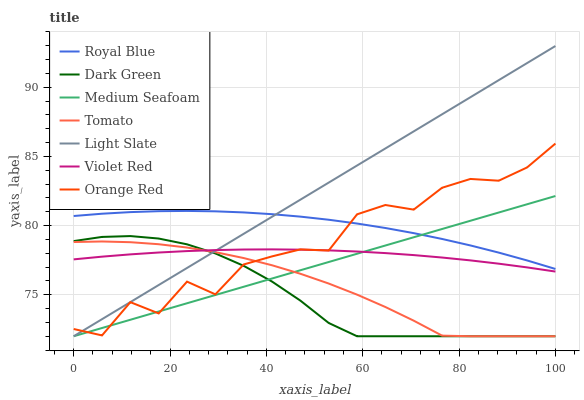Does Dark Green have the minimum area under the curve?
Answer yes or no. Yes. Does Light Slate have the maximum area under the curve?
Answer yes or no. Yes. Does Violet Red have the minimum area under the curve?
Answer yes or no. No. Does Violet Red have the maximum area under the curve?
Answer yes or no. No. Is Medium Seafoam the smoothest?
Answer yes or no. Yes. Is Orange Red the roughest?
Answer yes or no. Yes. Is Violet Red the smoothest?
Answer yes or no. No. Is Violet Red the roughest?
Answer yes or no. No. Does Violet Red have the lowest value?
Answer yes or no. No. Does Light Slate have the highest value?
Answer yes or no. Yes. Does Violet Red have the highest value?
Answer yes or no. No. Is Violet Red less than Royal Blue?
Answer yes or no. Yes. Is Royal Blue greater than Violet Red?
Answer yes or no. Yes. Does Violet Red intersect Tomato?
Answer yes or no. Yes. Is Violet Red less than Tomato?
Answer yes or no. No. Is Violet Red greater than Tomato?
Answer yes or no. No. Does Violet Red intersect Royal Blue?
Answer yes or no. No. 